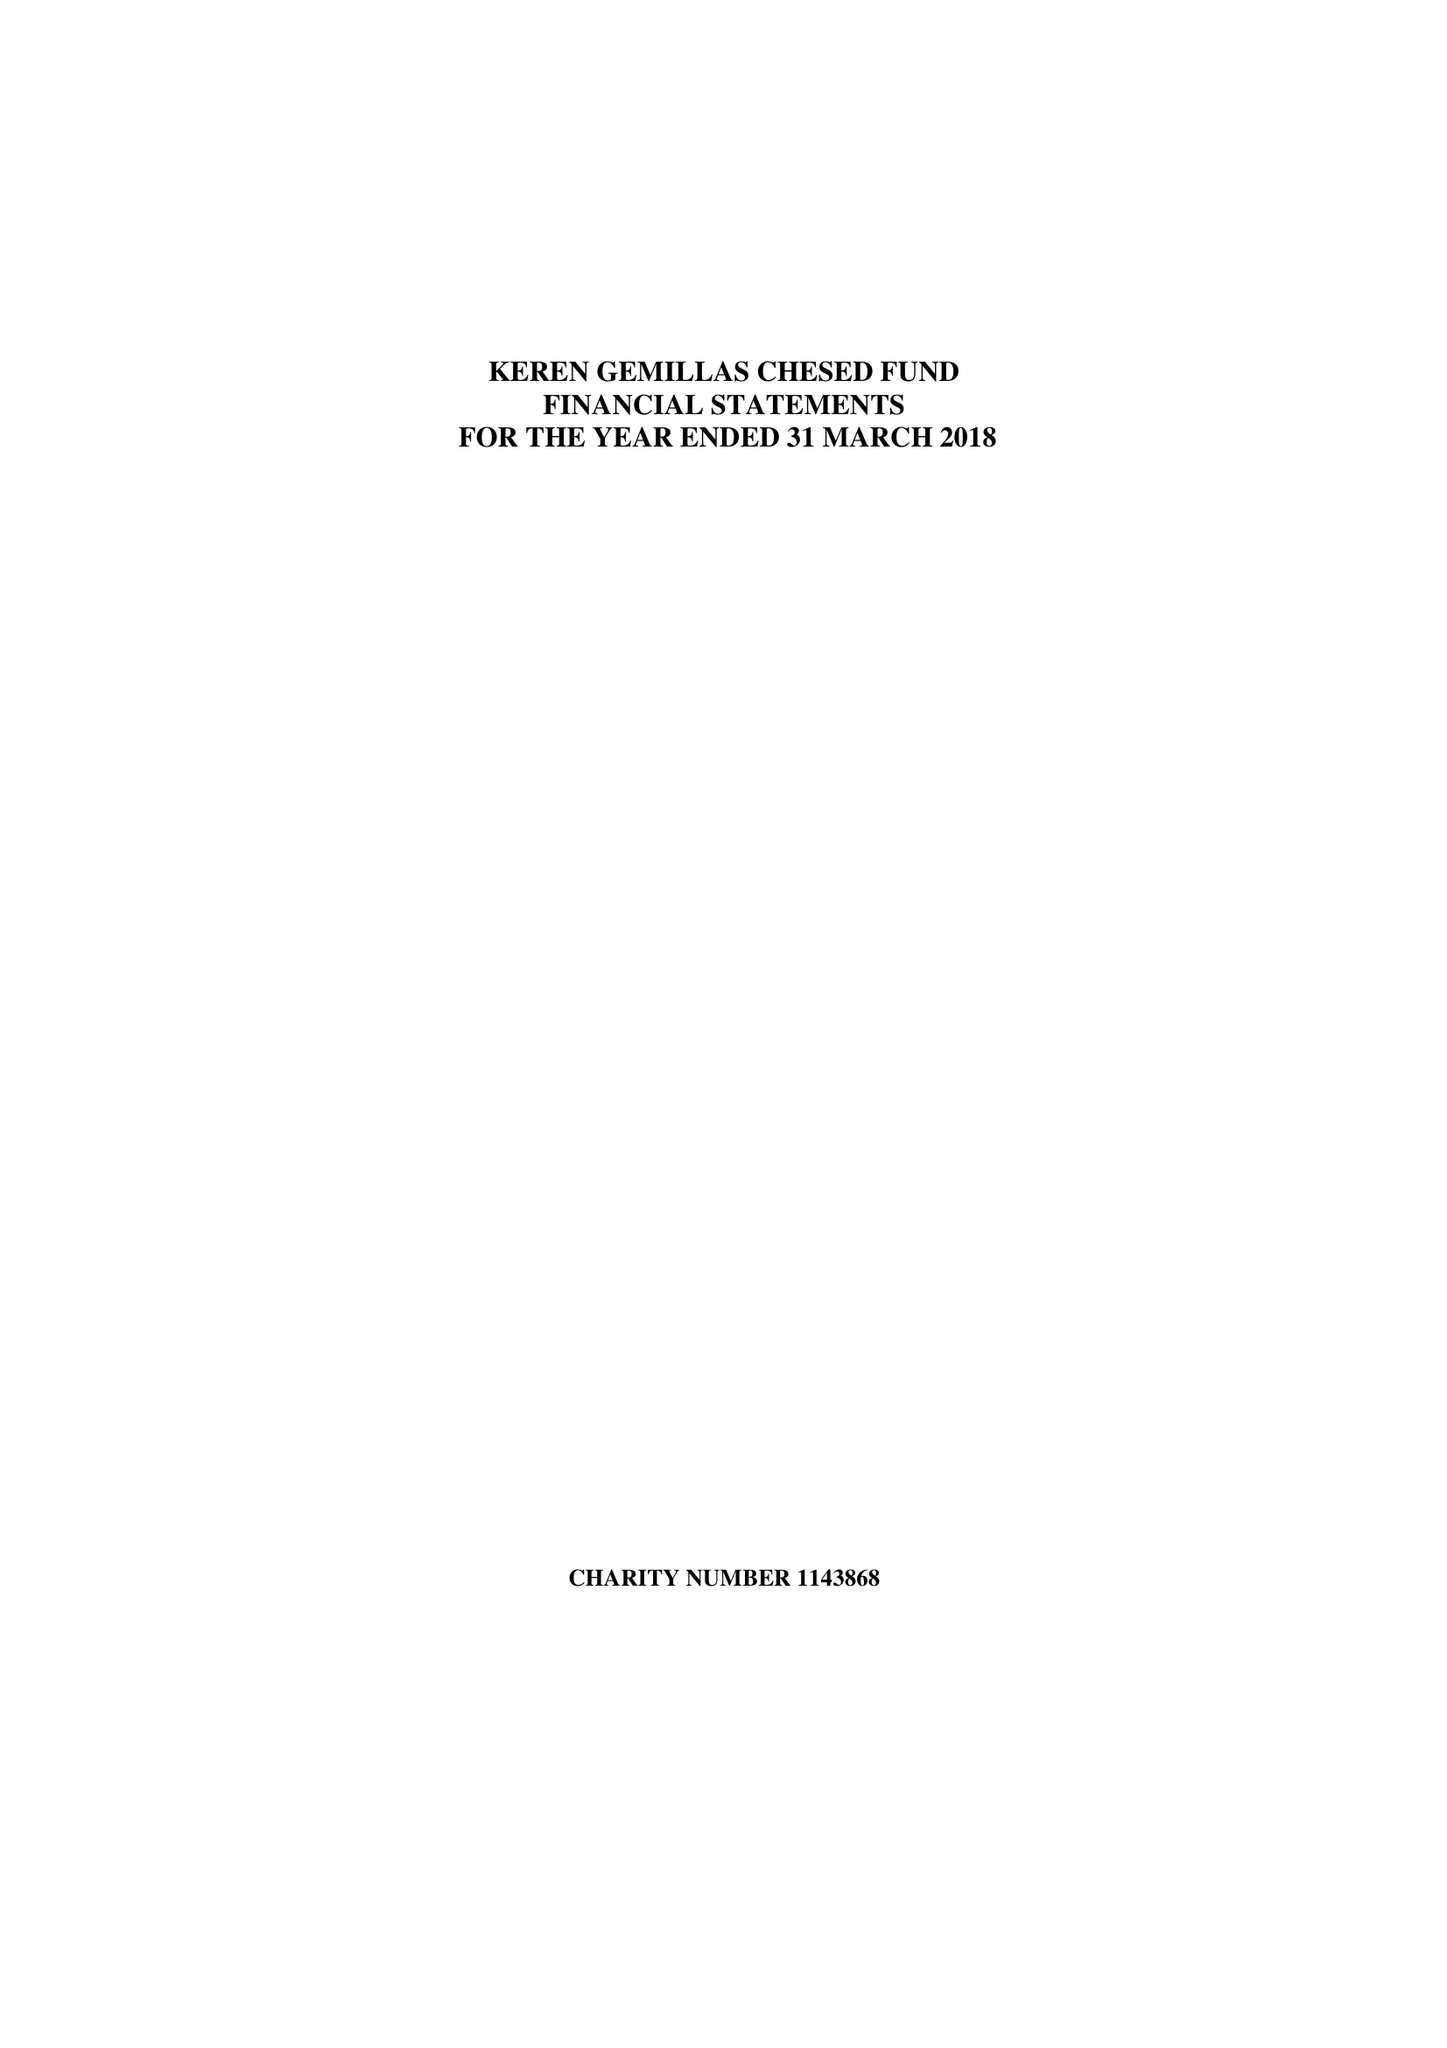What is the value for the address__postcode?
Answer the question using a single word or phrase. M7 4HQ 